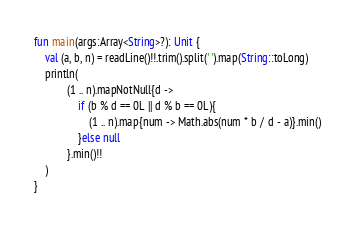<code> <loc_0><loc_0><loc_500><loc_500><_Kotlin_>fun main(args:Array<String>?): Unit {
    val (a, b, n) = readLine()!!.trim().split(' ').map(String::toLong)
    println(
            (1 .. n).mapNotNull{d ->
                if (b % d == 0L || d % b == 0L){
                    (1 .. n).map{num -> Math.abs(num * b / d - a)}.min()
                }else null
            }.min()!!
    )
}
</code> 